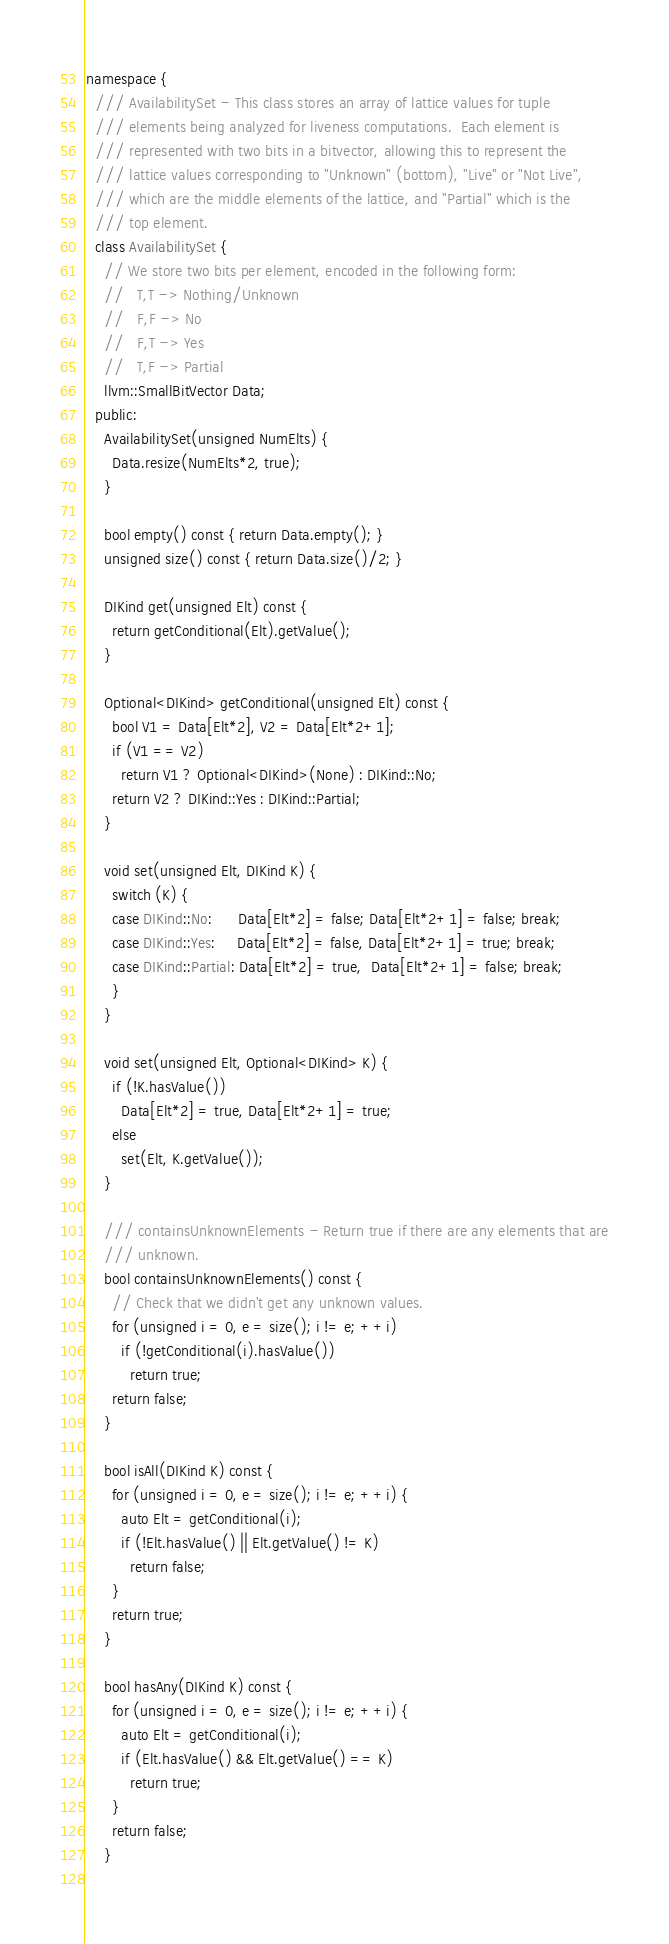<code> <loc_0><loc_0><loc_500><loc_500><_C++_>namespace {
  /// AvailabilitySet - This class stores an array of lattice values for tuple
  /// elements being analyzed for liveness computations.  Each element is
  /// represented with two bits in a bitvector, allowing this to represent the
  /// lattice values corresponding to "Unknown" (bottom), "Live" or "Not Live",
  /// which are the middle elements of the lattice, and "Partial" which is the
  /// top element.
  class AvailabilitySet {
    // We store two bits per element, encoded in the following form:
    //   T,T -> Nothing/Unknown
    //   F,F -> No
    //   F,T -> Yes
    //   T,F -> Partial
    llvm::SmallBitVector Data;
  public:
    AvailabilitySet(unsigned NumElts) {
      Data.resize(NumElts*2, true);
    }

    bool empty() const { return Data.empty(); }
    unsigned size() const { return Data.size()/2; }

    DIKind get(unsigned Elt) const {
      return getConditional(Elt).getValue();
    }

    Optional<DIKind> getConditional(unsigned Elt) const {
      bool V1 = Data[Elt*2], V2 = Data[Elt*2+1];
      if (V1 == V2)
        return V1 ? Optional<DIKind>(None) : DIKind::No;
      return V2 ? DIKind::Yes : DIKind::Partial;
    }

    void set(unsigned Elt, DIKind K) {
      switch (K) {
      case DIKind::No:      Data[Elt*2] = false; Data[Elt*2+1] = false; break;
      case DIKind::Yes:     Data[Elt*2] = false, Data[Elt*2+1] = true; break;
      case DIKind::Partial: Data[Elt*2] = true,  Data[Elt*2+1] = false; break;
      }
    }
    
    void set(unsigned Elt, Optional<DIKind> K) {
      if (!K.hasValue())
        Data[Elt*2] = true, Data[Elt*2+1] = true;
      else
        set(Elt, K.getValue());
    }

    /// containsUnknownElements - Return true if there are any elements that are
    /// unknown.
    bool containsUnknownElements() const {
      // Check that we didn't get any unknown values.
      for (unsigned i = 0, e = size(); i != e; ++i)
        if (!getConditional(i).hasValue())
          return true;
      return false;
    }

    bool isAll(DIKind K) const {
      for (unsigned i = 0, e = size(); i != e; ++i) {
        auto Elt = getConditional(i);
        if (!Elt.hasValue() || Elt.getValue() != K)
          return false;
      }
      return true;
    }
    
    bool hasAny(DIKind K) const {
      for (unsigned i = 0, e = size(); i != e; ++i) {
        auto Elt = getConditional(i);
        if (Elt.hasValue() && Elt.getValue() == K)
          return true;
      }
      return false;
    }
    </code> 